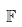<formula> <loc_0><loc_0><loc_500><loc_500>\mathbb { F }</formula> 